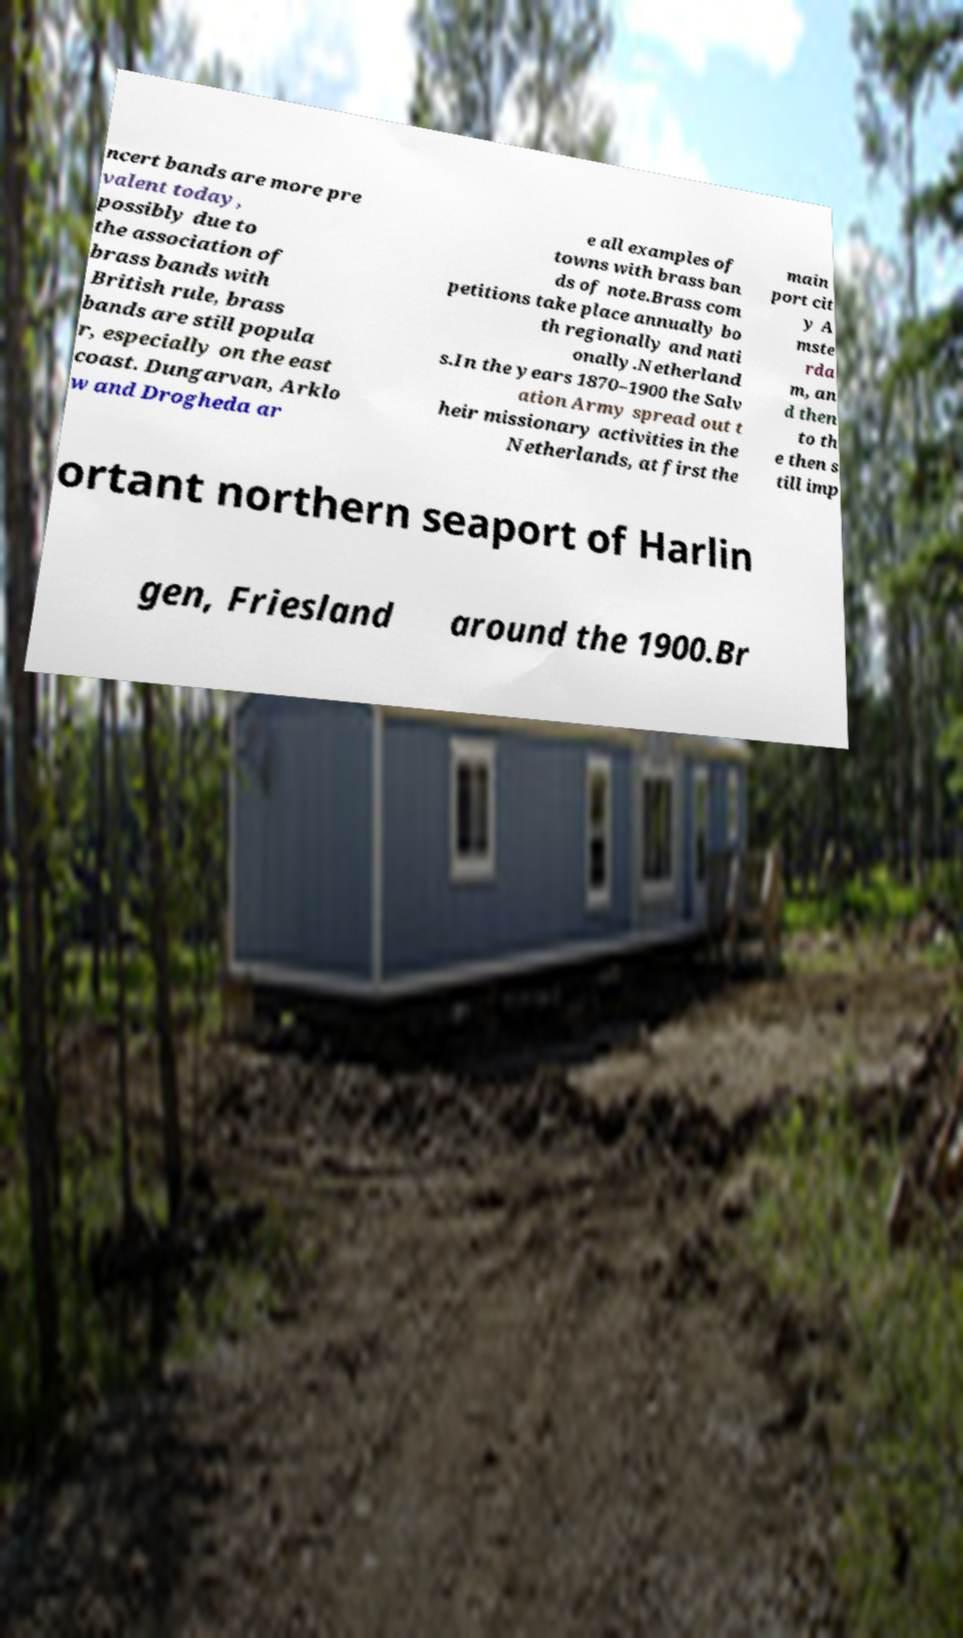Please identify and transcribe the text found in this image. ncert bands are more pre valent today, possibly due to the association of brass bands with British rule, brass bands are still popula r, especially on the east coast. Dungarvan, Arklo w and Drogheda ar e all examples of towns with brass ban ds of note.Brass com petitions take place annually bo th regionally and nati onally.Netherland s.In the years 1870–1900 the Salv ation Army spread out t heir missionary activities in the Netherlands, at first the main port cit y A mste rda m, an d then to th e then s till imp ortant northern seaport of Harlin gen, Friesland around the 1900.Br 